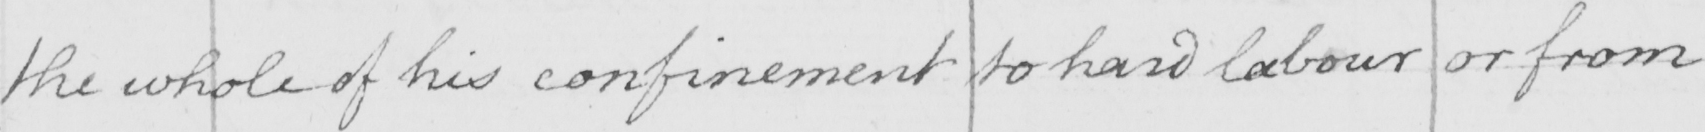Can you tell me what this handwritten text says? the whole of his confinement to hard labour or from 